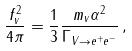Convert formula to latex. <formula><loc_0><loc_0><loc_500><loc_500>\frac { f _ { v } ^ { 2 } } { 4 \pi } = \frac { 1 } { 3 } \frac { m _ { v } \alpha ^ { 2 } } { \Gamma _ { V \rightarrow e ^ { + } e ^ { - } } } \, ,</formula> 